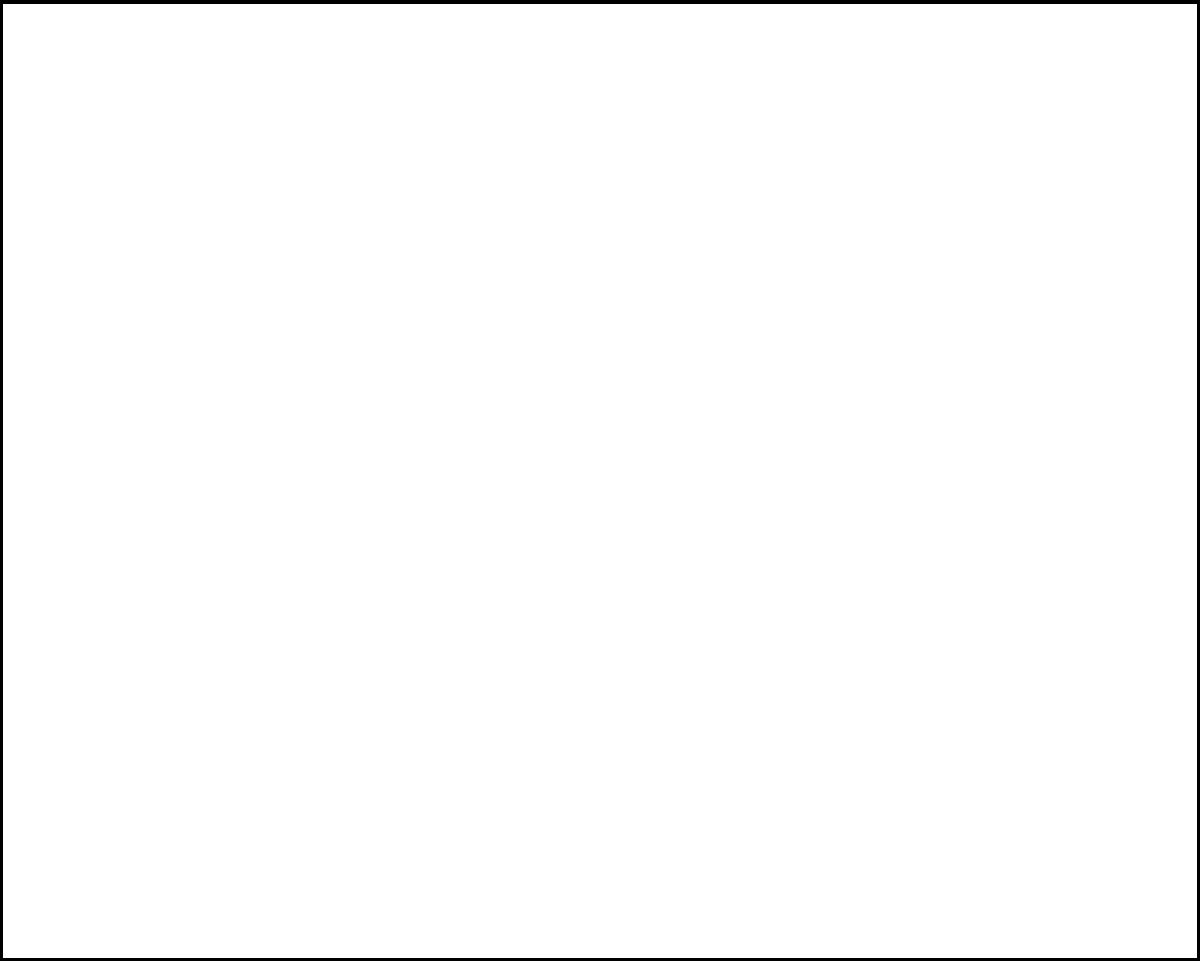As a police officer, you're tasked with assessing the extent of graffiti in a city block. The block measures 80m by 60m, and three walls have been covered with graffiti: the bottom wall from 20m to 60m, the right wall from 20m to 40m up, and the top wall from 30m to 70m. Calculate the total area of graffiti-covered walls. Let's calculate the area of each graffiti-covered wall:

1. Bottom wall (Wall 1):
   Length = 60m - 20m = 40m
   Height (assumed to be standard) = 3m
   Area = 40m × 3m = 120m²

2. Right wall (Wall 2):
   Length = 40m - 20m = 20m
   Width = 3m
   Area = 20m × 3m = 60m²

3. Top wall (Wall 3):
   Length = 70m - 30m = 40m
   Height = 3m
   Area = 40m × 3m = 120m²

Total graffiti-covered area:
$$120\text{m}^2 + 60\text{m}^2 + 120\text{m}^2 = 300\text{m}^2$$
Answer: 300m² 